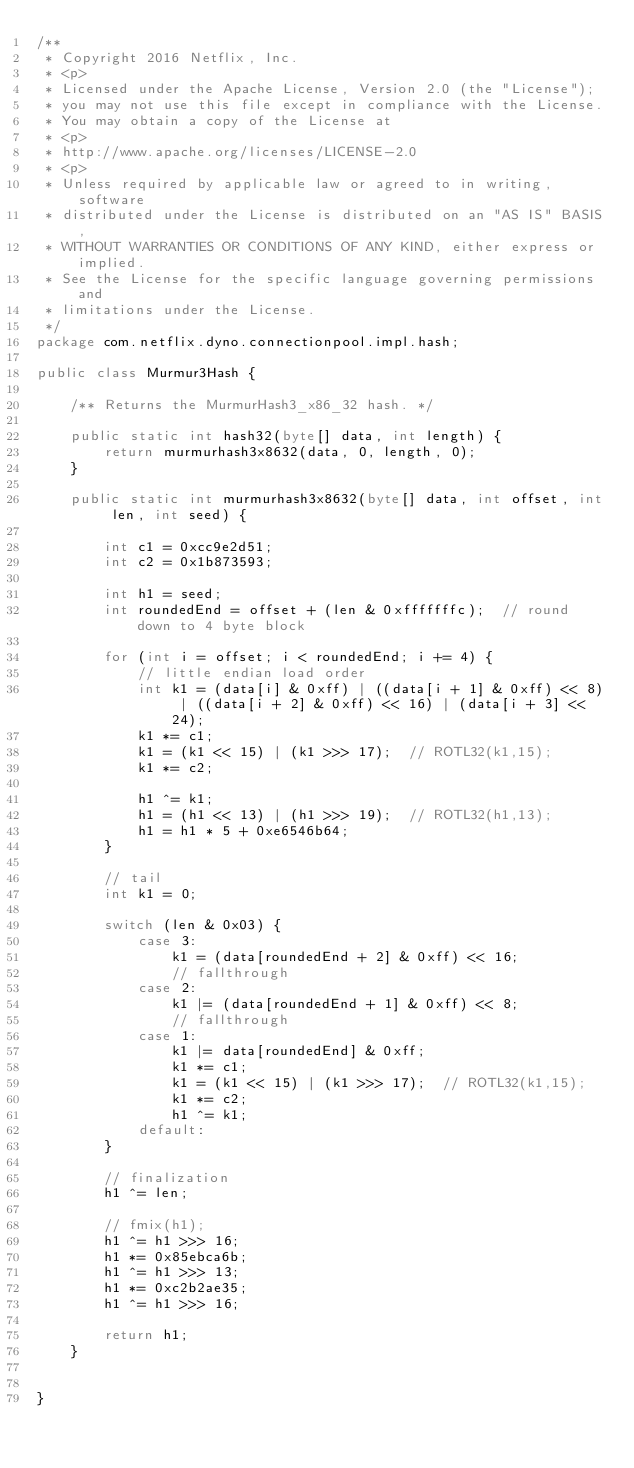<code> <loc_0><loc_0><loc_500><loc_500><_Java_>/**
 * Copyright 2016 Netflix, Inc.
 * <p>
 * Licensed under the Apache License, Version 2.0 (the "License");
 * you may not use this file except in compliance with the License.
 * You may obtain a copy of the License at
 * <p>
 * http://www.apache.org/licenses/LICENSE-2.0
 * <p>
 * Unless required by applicable law or agreed to in writing, software
 * distributed under the License is distributed on an "AS IS" BASIS,
 * WITHOUT WARRANTIES OR CONDITIONS OF ANY KIND, either express or implied.
 * See the License for the specific language governing permissions and
 * limitations under the License.
 */
package com.netflix.dyno.connectionpool.impl.hash;

public class Murmur3Hash {

    /** Returns the MurmurHash3_x86_32 hash. */

    public static int hash32(byte[] data, int length) {
        return murmurhash3x8632(data, 0, length, 0);
    }

    public static int murmurhash3x8632(byte[] data, int offset, int len, int seed) {

        int c1 = 0xcc9e2d51;
        int c2 = 0x1b873593;

        int h1 = seed;
        int roundedEnd = offset + (len & 0xfffffffc);  // round down to 4 byte block

        for (int i = offset; i < roundedEnd; i += 4) {
            // little endian load order
            int k1 = (data[i] & 0xff) | ((data[i + 1] & 0xff) << 8) | ((data[i + 2] & 0xff) << 16) | (data[i + 3] << 24);
            k1 *= c1;
            k1 = (k1 << 15) | (k1 >>> 17);  // ROTL32(k1,15);
            k1 *= c2;

            h1 ^= k1;
            h1 = (h1 << 13) | (h1 >>> 19);  // ROTL32(h1,13);
            h1 = h1 * 5 + 0xe6546b64;
        }

        // tail
        int k1 = 0;

        switch (len & 0x03) {
            case 3:
                k1 = (data[roundedEnd + 2] & 0xff) << 16;
                // fallthrough
            case 2:
                k1 |= (data[roundedEnd + 1] & 0xff) << 8;
                // fallthrough
            case 1:
                k1 |= data[roundedEnd] & 0xff;
                k1 *= c1;
                k1 = (k1 << 15) | (k1 >>> 17);  // ROTL32(k1,15);
                k1 *= c2;
                h1 ^= k1;
            default:
        }

        // finalization
        h1 ^= len;

        // fmix(h1);
        h1 ^= h1 >>> 16;
        h1 *= 0x85ebca6b;
        h1 ^= h1 >>> 13;
        h1 *= 0xc2b2ae35;
        h1 ^= h1 >>> 16;

        return h1;
    }


}
</code> 